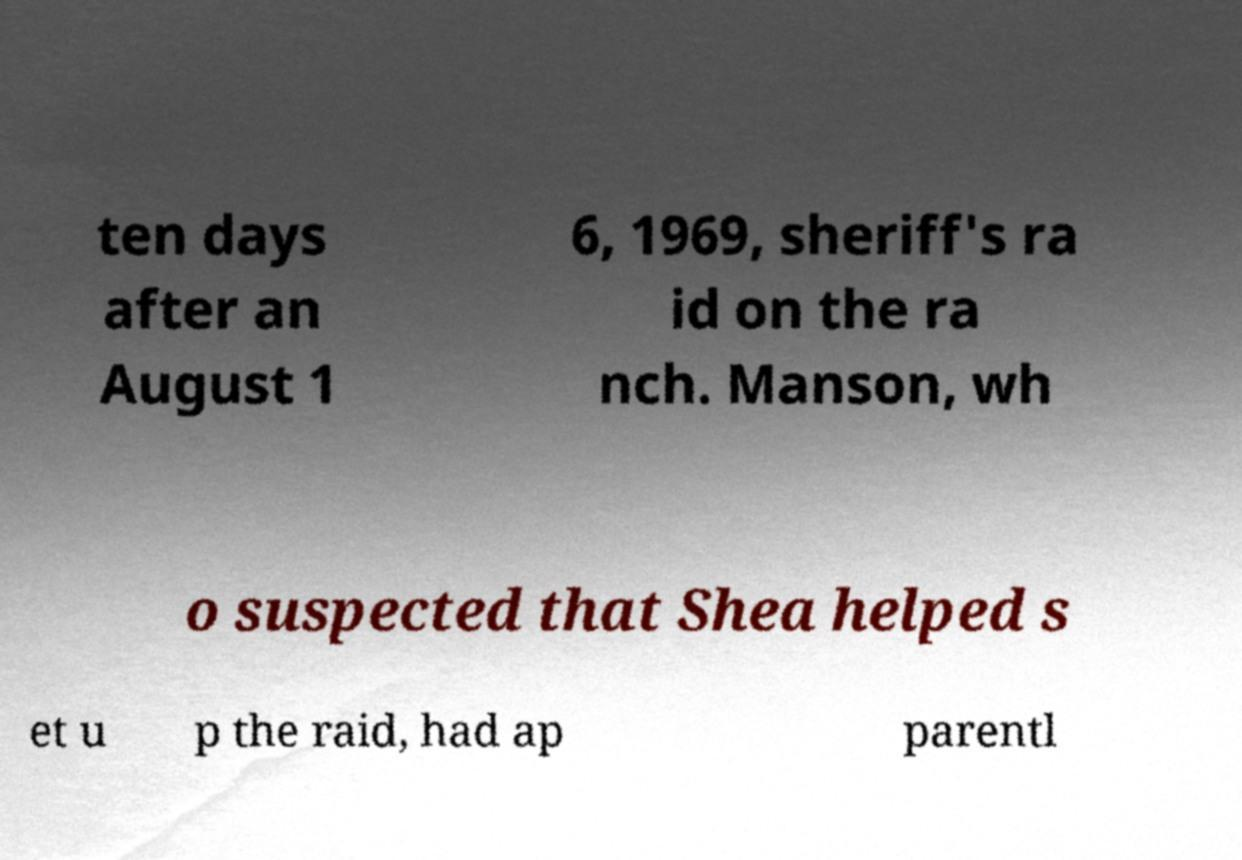Please read and relay the text visible in this image. What does it say? ten days after an August 1 6, 1969, sheriff's ra id on the ra nch. Manson, wh o suspected that Shea helped s et u p the raid, had ap parentl 